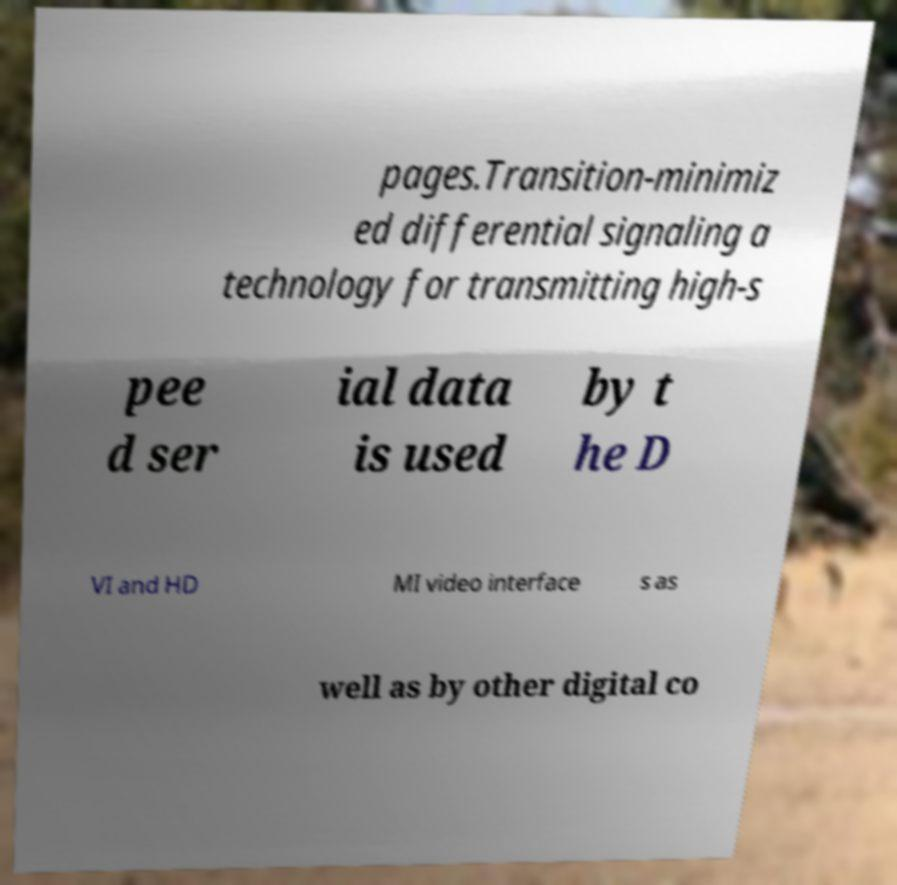Please read and relay the text visible in this image. What does it say? pages.Transition-minimiz ed differential signaling a technology for transmitting high-s pee d ser ial data is used by t he D VI and HD MI video interface s as well as by other digital co 